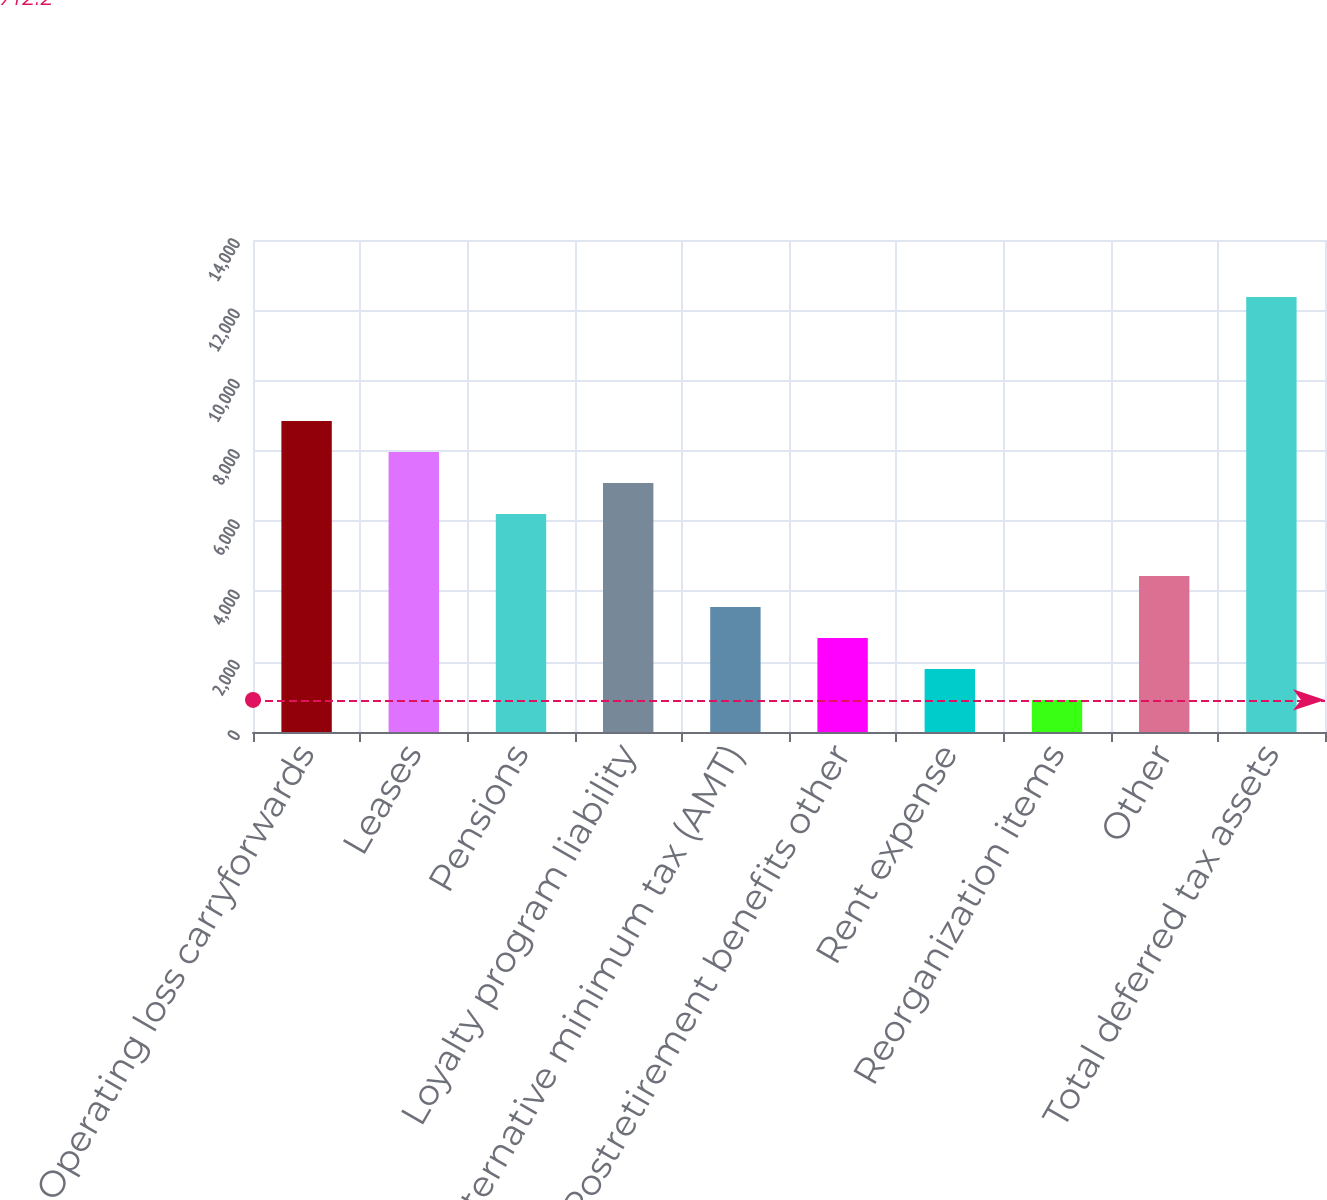<chart> <loc_0><loc_0><loc_500><loc_500><bar_chart><fcel>Operating loss carryforwards<fcel>Leases<fcel>Pensions<fcel>Loyalty program liability<fcel>Alternative minimum tax (AMT)<fcel>Postretirement benefits other<fcel>Rent expense<fcel>Reorganization items<fcel>Other<fcel>Total deferred tax assets<nl><fcel>8852<fcel>7969.8<fcel>6205.4<fcel>7087.6<fcel>3558.8<fcel>2676.6<fcel>1794.4<fcel>912.2<fcel>4441<fcel>12380.8<nl></chart> 